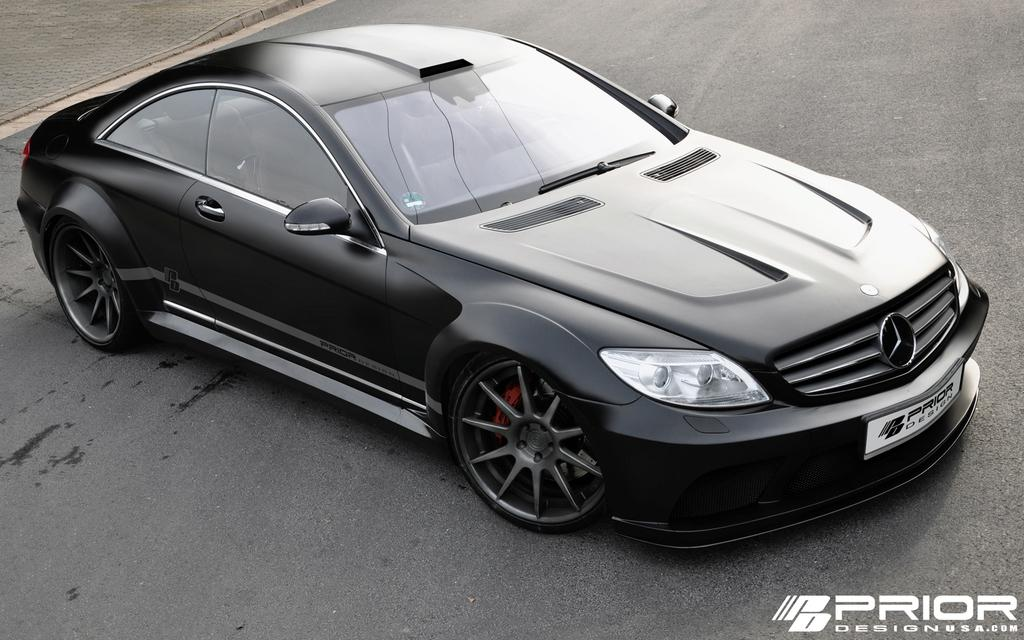What color is the car in the image? The car in the image is black. Where is the car located in the image? The car is on a road. What type of decision is the car making in the image? The car is not making a decision in the image; it is simply on a road. Can you see any bones in the image? There are no bones present in the image. 